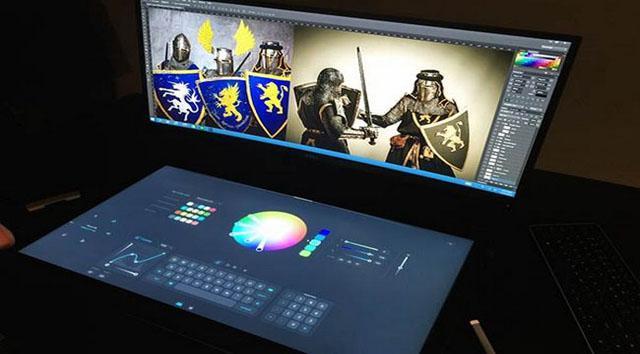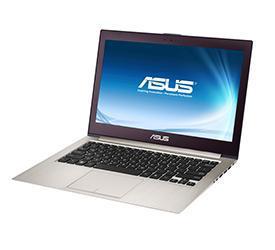The first image is the image on the left, the second image is the image on the right. Given the left and right images, does the statement "The laptop on the right has a slightly curved, concave screen." hold true? Answer yes or no. No. 